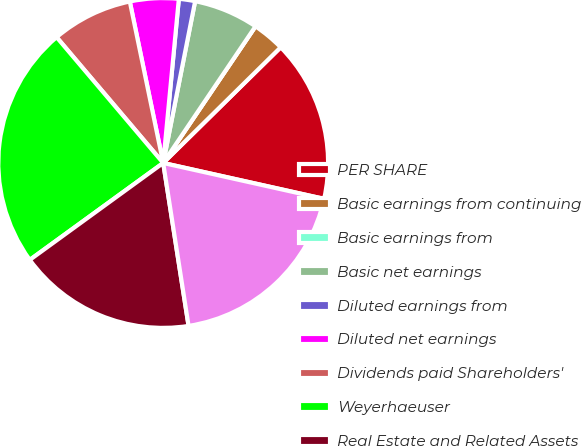<chart> <loc_0><loc_0><loc_500><loc_500><pie_chart><fcel>PER SHARE<fcel>Basic earnings from continuing<fcel>Basic earnings from<fcel>Basic net earnings<fcel>Diluted earnings from<fcel>Diluted net earnings<fcel>Dividends paid Shareholders'<fcel>Weyerhaeuser<fcel>Real Estate and Related Assets<fcel>Long-term debt<nl><fcel>15.87%<fcel>3.17%<fcel>0.0%<fcel>6.35%<fcel>1.59%<fcel>4.76%<fcel>7.94%<fcel>23.81%<fcel>17.46%<fcel>19.05%<nl></chart> 